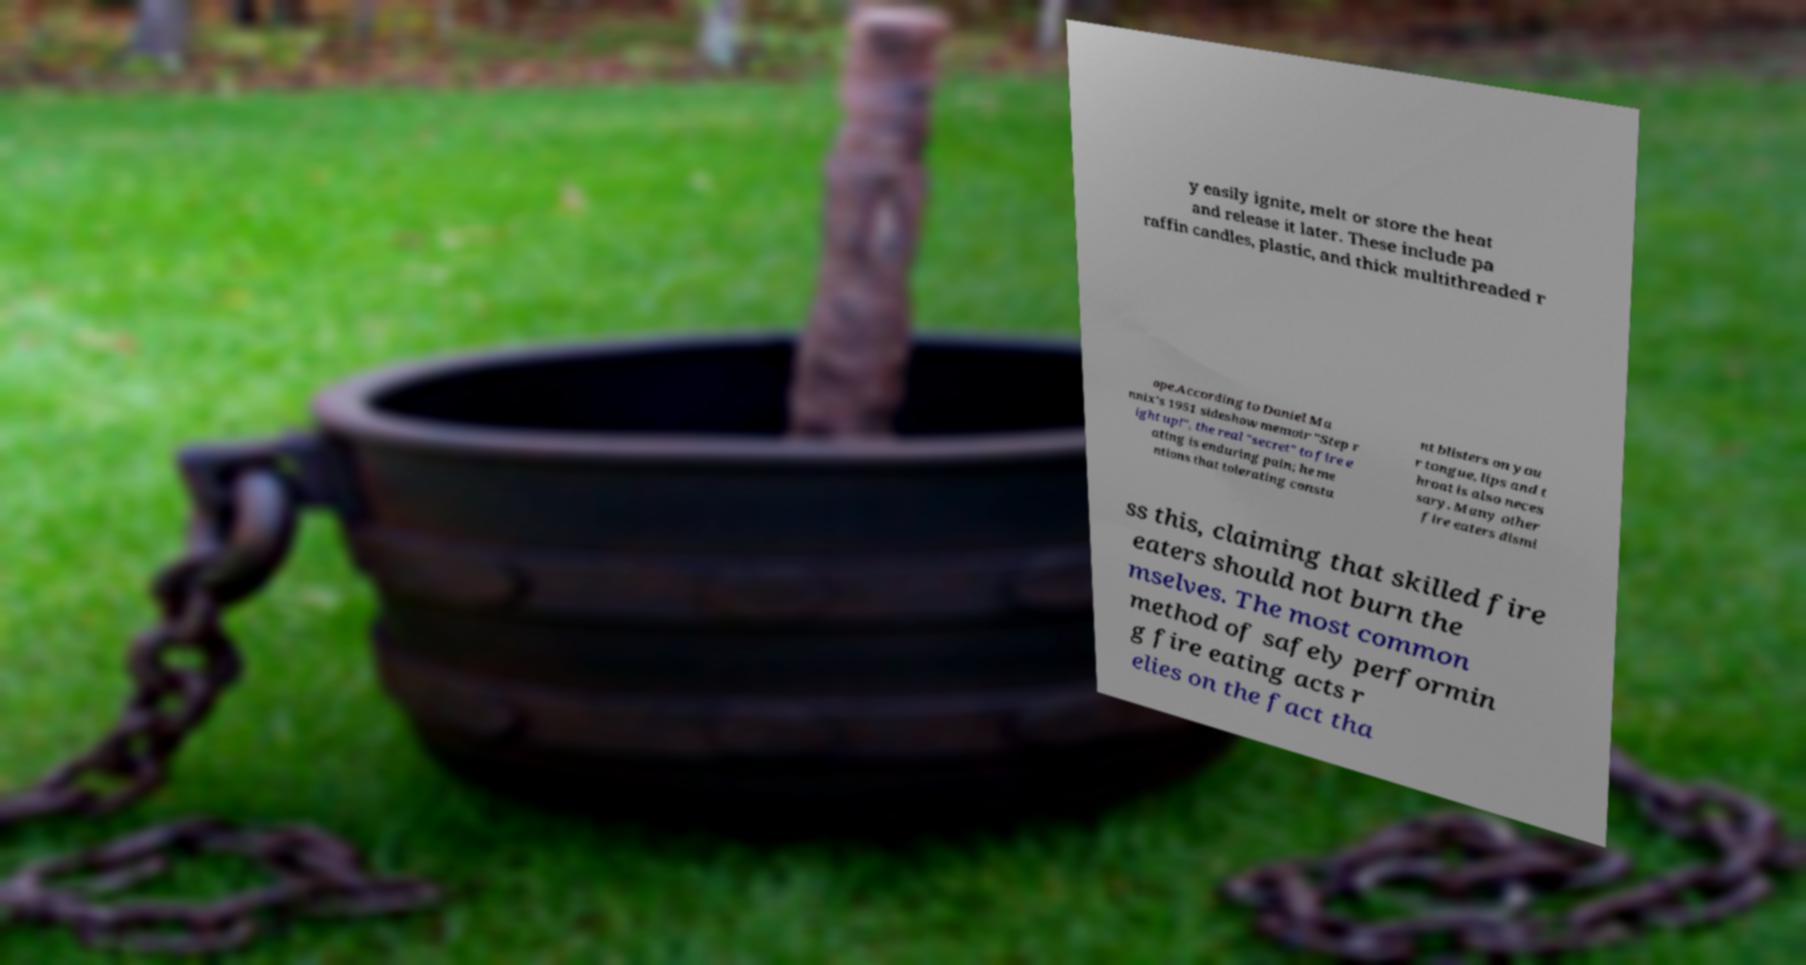There's text embedded in this image that I need extracted. Can you transcribe it verbatim? y easily ignite, melt or store the heat and release it later. These include pa raffin candles, plastic, and thick multithreaded r ope.According to Daniel Ma nnix's 1951 sideshow memoir "Step r ight up!", the real "secret" to fire e ating is enduring pain; he me ntions that tolerating consta nt blisters on you r tongue, lips and t hroat is also neces sary. Many other fire eaters dismi ss this, claiming that skilled fire eaters should not burn the mselves. The most common method of safely performin g fire eating acts r elies on the fact tha 